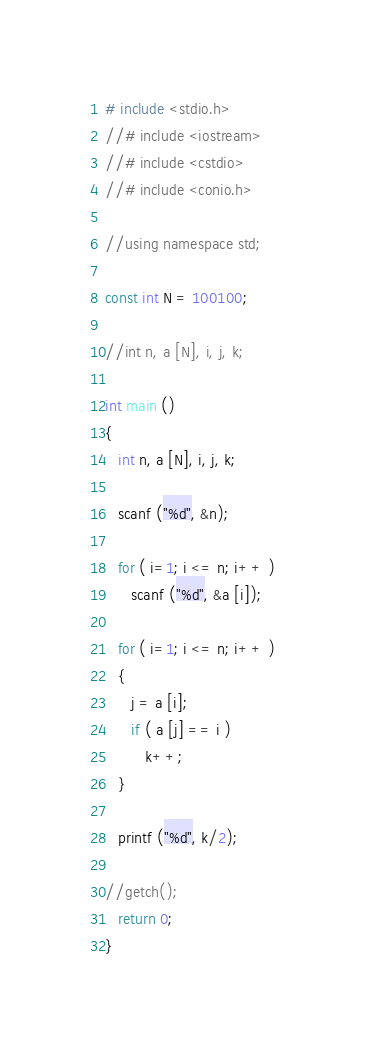<code> <loc_0><loc_0><loc_500><loc_500><_C_># include <stdio.h>
//# include <iostream>
//# include <cstdio>
//# include <conio.h>

//using namespace std;

const int N = 100100;

//int n, a [N], i, j, k;

int main ()
{
   int n, a [N], i, j, k;

   scanf ("%d", &n);
   
   for ( i=1; i <= n; i++ )
      scanf ("%d", &a [i]);

   for ( i=1; i <= n; i++ )
   {
      j = a [i];
      if ( a [j] == i )
         k++;
   }

   printf ("%d", k/2);

//getch();
   return 0;
}
</code> 